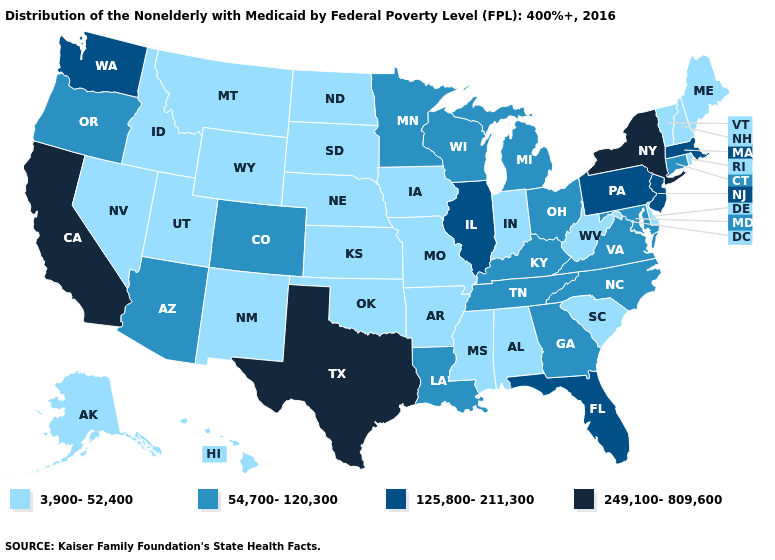Is the legend a continuous bar?
Give a very brief answer. No. Name the states that have a value in the range 125,800-211,300?
Write a very short answer. Florida, Illinois, Massachusetts, New Jersey, Pennsylvania, Washington. What is the value of South Dakota?
Give a very brief answer. 3,900-52,400. Does Kansas have a lower value than Nebraska?
Answer briefly. No. What is the value of Massachusetts?
Short answer required. 125,800-211,300. What is the value of Washington?
Answer briefly. 125,800-211,300. What is the value of Utah?
Short answer required. 3,900-52,400. Among the states that border Ohio , which have the highest value?
Be succinct. Pennsylvania. Name the states that have a value in the range 125,800-211,300?
Give a very brief answer. Florida, Illinois, Massachusetts, New Jersey, Pennsylvania, Washington. Does the first symbol in the legend represent the smallest category?
Concise answer only. Yes. Which states have the lowest value in the South?
Quick response, please. Alabama, Arkansas, Delaware, Mississippi, Oklahoma, South Carolina, West Virginia. Name the states that have a value in the range 125,800-211,300?
Write a very short answer. Florida, Illinois, Massachusetts, New Jersey, Pennsylvania, Washington. What is the value of Iowa?
Quick response, please. 3,900-52,400. Which states hav the highest value in the Northeast?
Give a very brief answer. New York. Does Maine have the same value as Washington?
Quick response, please. No. 